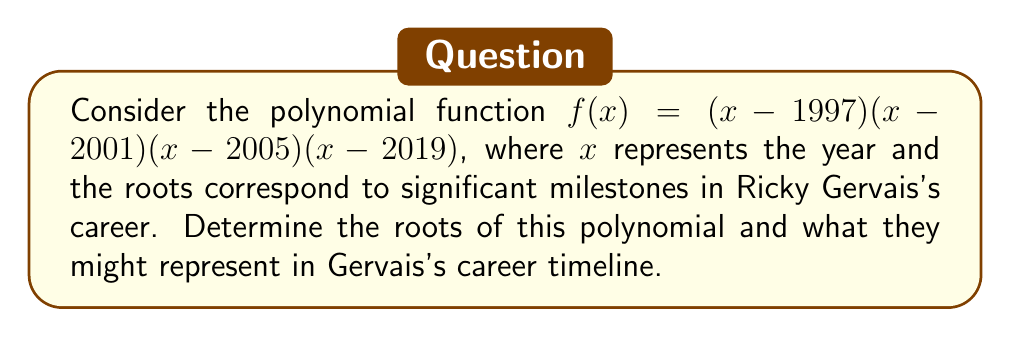Solve this math problem. To find the roots of the polynomial function, we need to identify the values of $x$ that make $f(x) = 0$. In this case, the polynomial is already factored, so we can easily determine the roots:

1. Set each factor to zero and solve for $x$:
   $(x-1997) = 0$, $x = 1997$
   $(x-2001) = 0$, $x = 2001$
   $(x-2005) = 0$, $x = 2005$
   $(x-2019) = 0$, $x = 2019$

2. These roots correspond to significant years in Ricky Gervais's career:
   - 1997: Gervais began his career in radio, hosting a show on London's XFM.
   - 2001: "The Office" (UK version) premiered, launching Gervais to international fame.
   - 2005: Gervais's podcast "The Ricky Gervais Show" began, becoming one of the most downloaded podcasts.
   - 2019: Gervais's critically acclaimed series "After Life" premiered on Netflix.

The polynomial function $f(x)$ reaches zero at these four points, representing the years of these career milestones.
Answer: Roots: 1997, 2001, 2005, 2019 